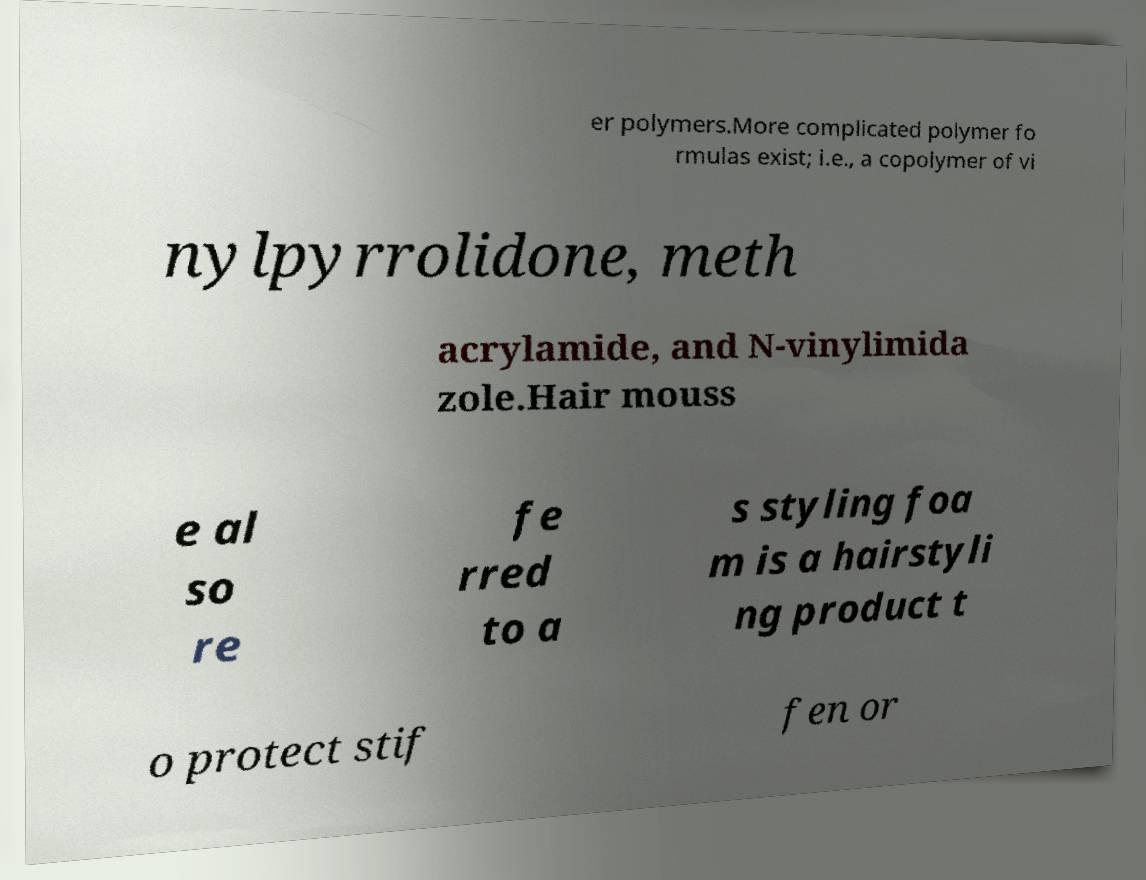I need the written content from this picture converted into text. Can you do that? er polymers.More complicated polymer fo rmulas exist; i.e., a copolymer of vi nylpyrrolidone, meth acrylamide, and N-vinylimida zole.Hair mouss e al so re fe rred to a s styling foa m is a hairstyli ng product t o protect stif fen or 